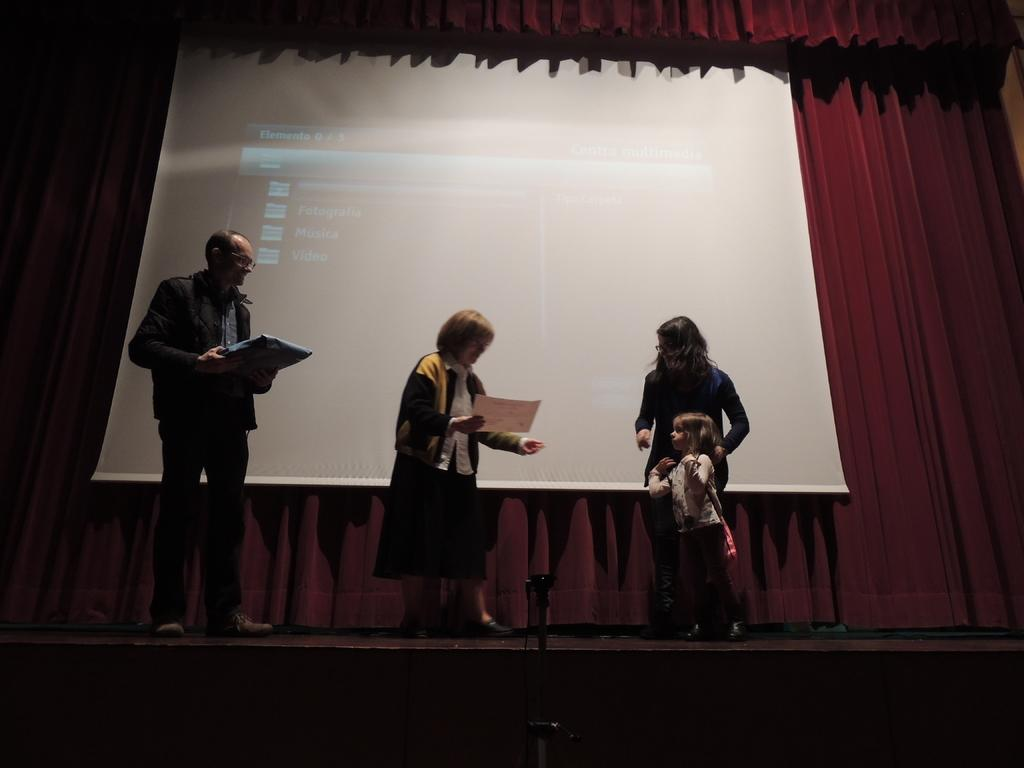How many people are present in the image? There are four people in the image. What can be observed about the clothing of the people in the image? The people are wearing different color dresses. What are two of the people doing in the image? Two people are holding objects. What can be seen in the background of the image? There is a screen and a maroon color curtain in the background of the image. What type of skirt is the person on the left wearing in the image? There is no skirt visible in the image; the people are wearing dresses. How many eyes does the person in the middle have in the image? The image does not show the number of eyes the people have; it only shows their faces from a distance. 